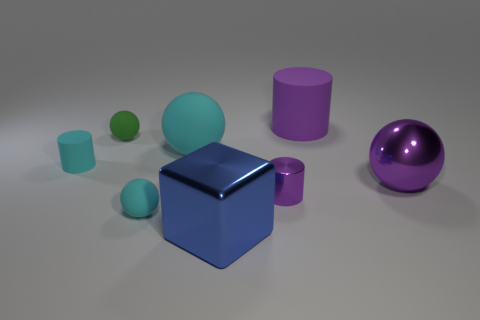What number of small red rubber balls are there?
Ensure brevity in your answer.  0. Is the size of the blue metallic block the same as the cyan matte cylinder?
Provide a succinct answer. No. Is there a metallic object of the same color as the large matte ball?
Ensure brevity in your answer.  No. There is a large matte thing that is right of the blue shiny object; is its shape the same as the small green rubber object?
Provide a succinct answer. No. What number of rubber cylinders are the same size as the blue block?
Offer a terse response. 1. How many shiny balls are behind the small green matte ball to the left of the tiny metal thing?
Offer a terse response. 0. Is the large ball that is in front of the cyan rubber cylinder made of the same material as the big blue cube?
Your response must be concise. Yes. Does the large thing that is to the left of the blue metal object have the same material as the ball behind the big cyan matte ball?
Provide a short and direct response. Yes. Is the number of purple things behind the small purple shiny cylinder greater than the number of tiny gray rubber things?
Keep it short and to the point. Yes. There is a object that is in front of the rubber thing in front of the purple metal sphere; what is its color?
Ensure brevity in your answer.  Blue. 